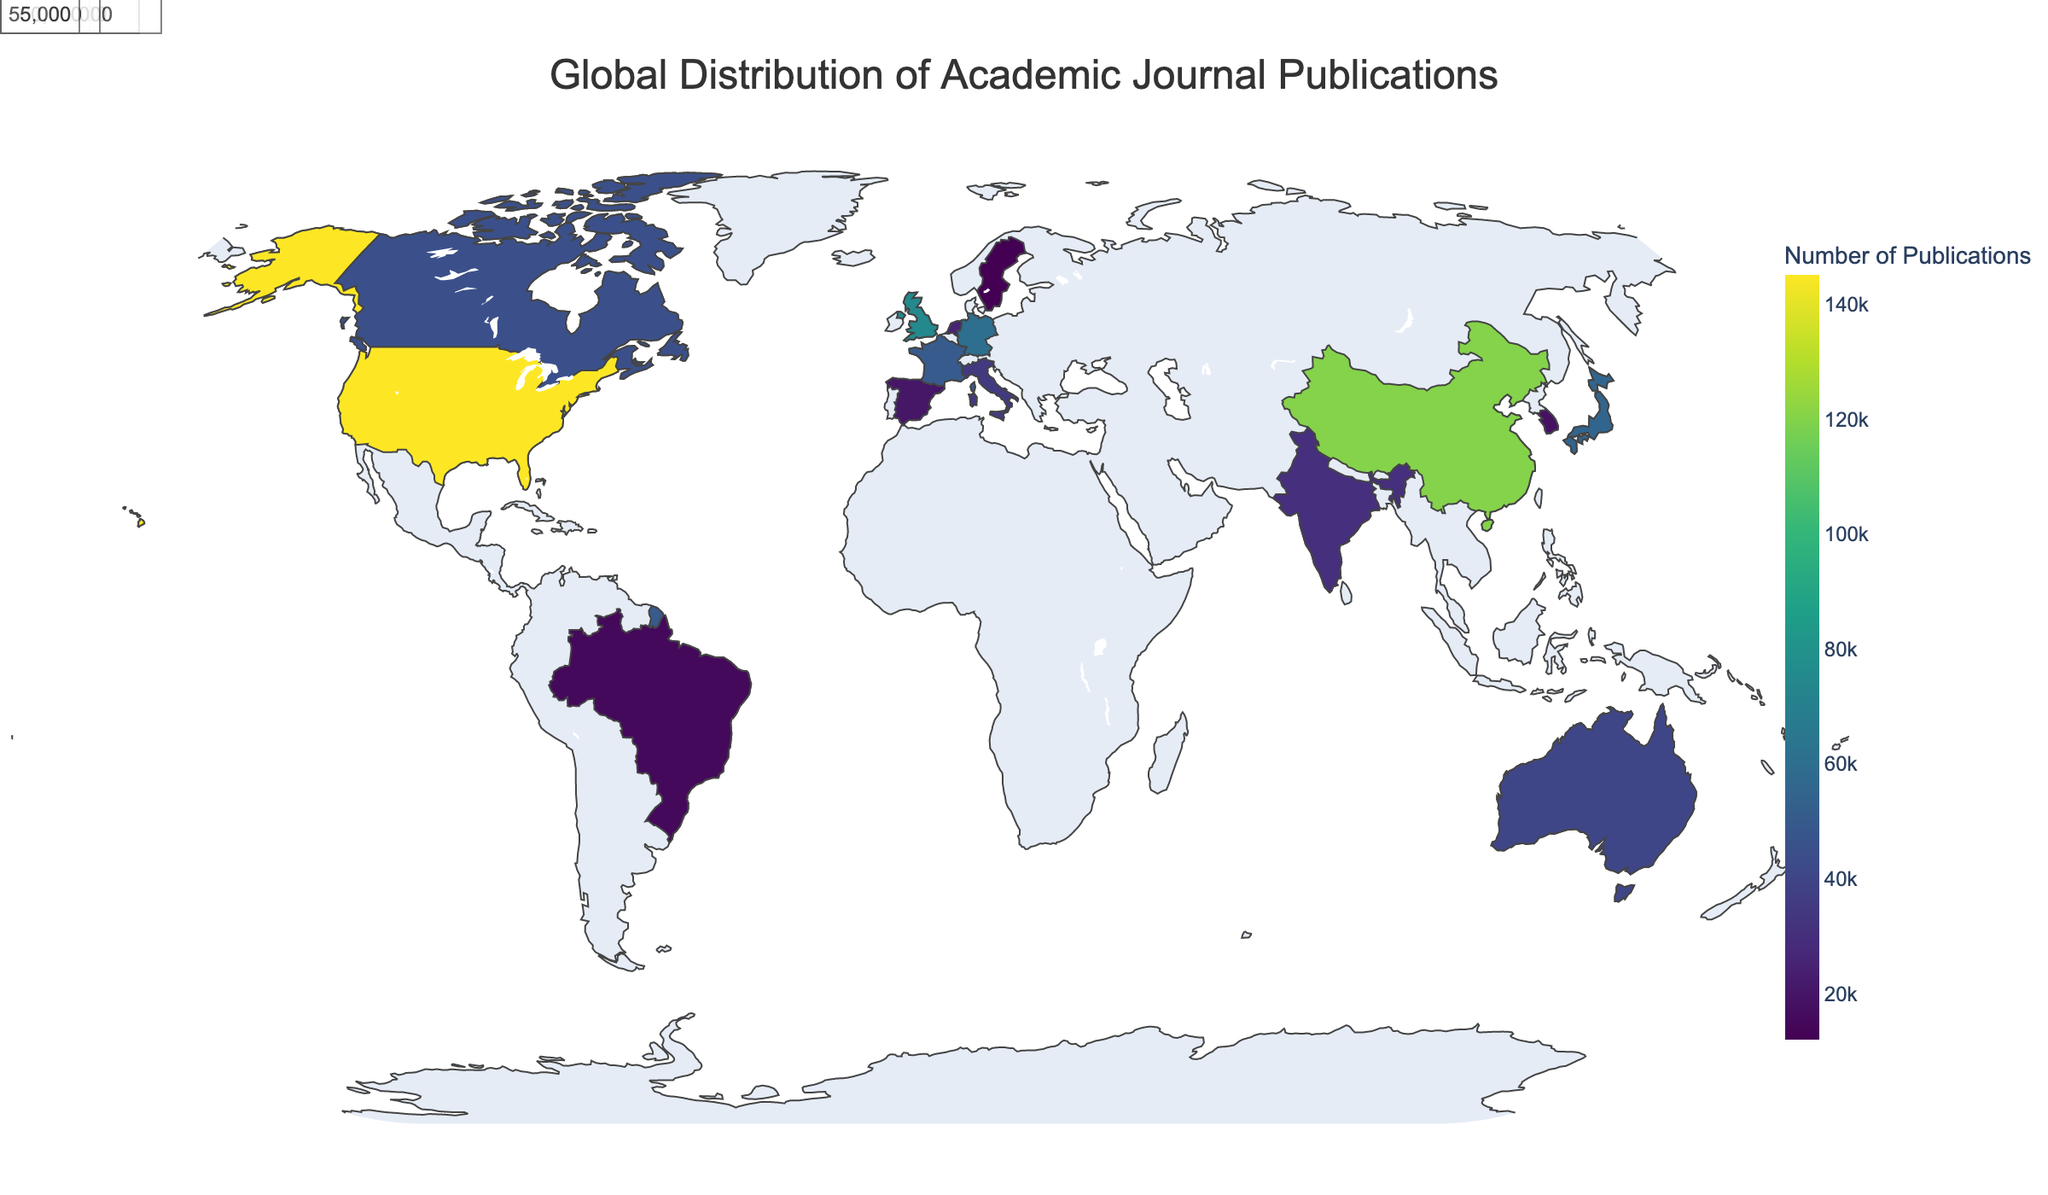What's the title of the plot? The title is the largest text and it appears at the top of the plot. It helps to understand the subject of the visualization.
Answer: Global Distribution of Academic Journal Publications Which country has the highest number of publications? The plot uses a color scale to represent the number of publications, with darker colors indicating higher numbers. By identifying the country with the darkest shade, we determine the country with the most publications.
Answer: United States Name two fields of study for which the corresponding countries are among the top 5 in publications. The plot includes text annotations for the top 5 countries. By looking at the annotations, we can identify the fields of study for those countries.
Answer: Medicine (United States), Engineering (China) What is the total number of publications for the United States and China combined? Sum the number of publications for the United States and China from the annotations or data.
Answer: 265,000 Which country has the fewest publications and what is the field of study associated with it? By checking the country with the lightest shade on the plot, we can identify the country with the fewest publications and reference the data to determine its associated field of study.
Answer: Sweden, Linguistics What is the average number of publications among the top 5 countries? Sum the publications for the top 5 countries and divide by 5. The top 5 countries are United States, China, United Kingdom, Germany, and Japan.
Answer: (145,000 + 120,000 + 75,000 + 60,000 + 55,000) / 5 = 91,000 How does the number of publications in Canada compare to that of Australia? Identify the number of publications for Canada and Australia from the plot or data, then compare them directly.
Answer: Canada has more publications (45,000) compared to Australia (40,000) Which continent appears to have the highest concentration of publications based on the geographic distribution? By looking at the darker shades across different continents, we can determine which continent has the highest concentration of publications.
Answer: North America Is there a significant difference between the publications of Germany and France? How many more publications does Germany have compared to France? Subtract the number of publications in France from those in Germany to find the difference.
Answer: 60,000 - 50,000 = 10,000 